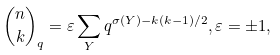Convert formula to latex. <formula><loc_0><loc_0><loc_500><loc_500>\binom { n } { k } _ { q } = \varepsilon \sum _ { Y } q ^ { \sigma ( Y ) - k ( k - 1 ) / 2 } , \varepsilon = \pm 1 ,</formula> 